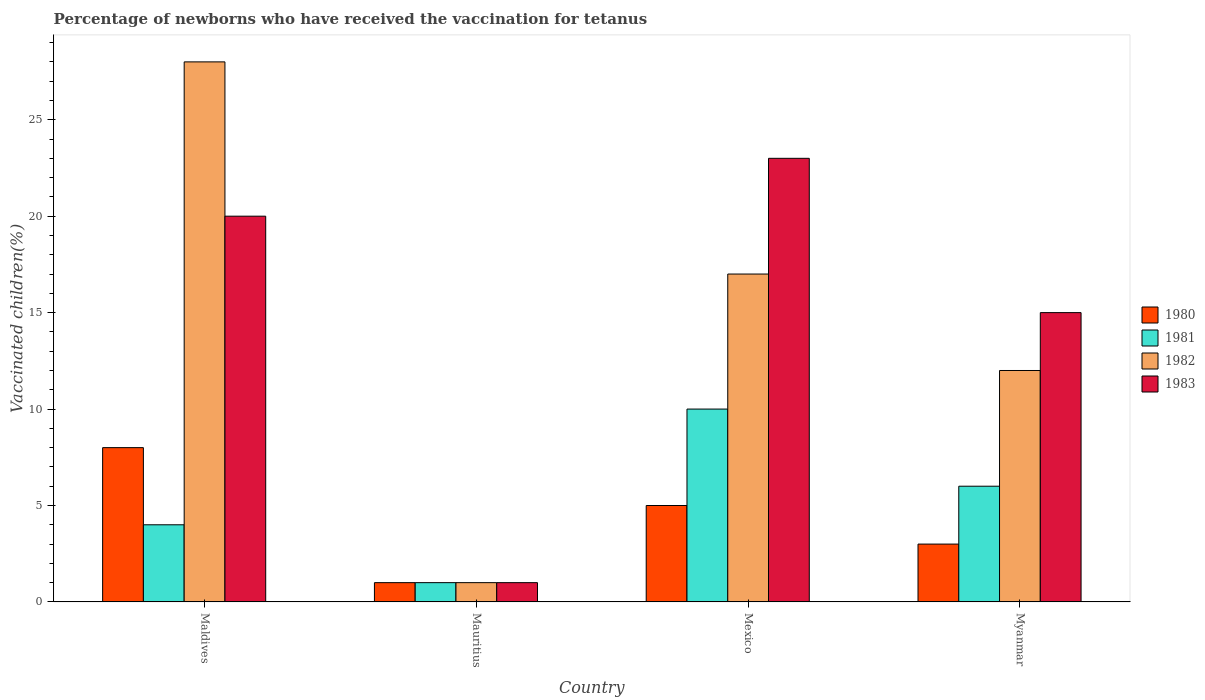Are the number of bars per tick equal to the number of legend labels?
Offer a terse response. Yes. Are the number of bars on each tick of the X-axis equal?
Ensure brevity in your answer.  Yes. What is the label of the 2nd group of bars from the left?
Your answer should be very brief. Mauritius. In which country was the percentage of vaccinated children in 1982 minimum?
Ensure brevity in your answer.  Mauritius. What is the total percentage of vaccinated children in 1981 in the graph?
Offer a terse response. 21. What is the difference between the percentage of vaccinated children in 1981 in Maldives and that in Mexico?
Provide a succinct answer. -6. What is the difference between the percentage of vaccinated children in 1982 in Mauritius and the percentage of vaccinated children in 1983 in Mexico?
Your answer should be compact. -22. What is the average percentage of vaccinated children in 1980 per country?
Provide a succinct answer. 4.25. What is the difference between the percentage of vaccinated children of/in 1981 and percentage of vaccinated children of/in 1982 in Myanmar?
Your answer should be very brief. -6. In how many countries, is the percentage of vaccinated children in 1982 greater than 12 %?
Provide a succinct answer. 2. What is the ratio of the percentage of vaccinated children in 1981 in Maldives to that in Myanmar?
Offer a very short reply. 0.67. In how many countries, is the percentage of vaccinated children in 1983 greater than the average percentage of vaccinated children in 1983 taken over all countries?
Offer a terse response. 3. Is the sum of the percentage of vaccinated children in 1980 in Maldives and Mauritius greater than the maximum percentage of vaccinated children in 1983 across all countries?
Offer a very short reply. No. How many bars are there?
Make the answer very short. 16. Are all the bars in the graph horizontal?
Keep it short and to the point. No. Does the graph contain any zero values?
Provide a succinct answer. No. Where does the legend appear in the graph?
Your answer should be compact. Center right. How are the legend labels stacked?
Your response must be concise. Vertical. What is the title of the graph?
Provide a succinct answer. Percentage of newborns who have received the vaccination for tetanus. What is the label or title of the Y-axis?
Provide a short and direct response. Vaccinated children(%). What is the Vaccinated children(%) in 1981 in Maldives?
Provide a short and direct response. 4. What is the Vaccinated children(%) in 1983 in Mauritius?
Ensure brevity in your answer.  1. What is the Vaccinated children(%) in 1982 in Myanmar?
Your response must be concise. 12. Across all countries, what is the maximum Vaccinated children(%) of 1981?
Your response must be concise. 10. Across all countries, what is the minimum Vaccinated children(%) in 1980?
Your answer should be compact. 1. Across all countries, what is the minimum Vaccinated children(%) of 1981?
Ensure brevity in your answer.  1. Across all countries, what is the minimum Vaccinated children(%) in 1982?
Ensure brevity in your answer.  1. What is the total Vaccinated children(%) of 1981 in the graph?
Your answer should be very brief. 21. What is the difference between the Vaccinated children(%) in 1980 in Maldives and that in Mauritius?
Your answer should be very brief. 7. What is the difference between the Vaccinated children(%) of 1982 in Maldives and that in Mauritius?
Make the answer very short. 27. What is the difference between the Vaccinated children(%) in 1983 in Maldives and that in Mauritius?
Give a very brief answer. 19. What is the difference between the Vaccinated children(%) of 1981 in Maldives and that in Myanmar?
Ensure brevity in your answer.  -2. What is the difference between the Vaccinated children(%) of 1983 in Maldives and that in Myanmar?
Keep it short and to the point. 5. What is the difference between the Vaccinated children(%) of 1980 in Mauritius and that in Mexico?
Your response must be concise. -4. What is the difference between the Vaccinated children(%) in 1981 in Mauritius and that in Mexico?
Give a very brief answer. -9. What is the difference between the Vaccinated children(%) in 1982 in Mauritius and that in Mexico?
Provide a succinct answer. -16. What is the difference between the Vaccinated children(%) in 1981 in Mauritius and that in Myanmar?
Give a very brief answer. -5. What is the difference between the Vaccinated children(%) in 1982 in Mauritius and that in Myanmar?
Your answer should be very brief. -11. What is the difference between the Vaccinated children(%) in 1983 in Mauritius and that in Myanmar?
Give a very brief answer. -14. What is the difference between the Vaccinated children(%) of 1981 in Mexico and that in Myanmar?
Give a very brief answer. 4. What is the difference between the Vaccinated children(%) in 1982 in Mexico and that in Myanmar?
Your response must be concise. 5. What is the difference between the Vaccinated children(%) in 1980 in Maldives and the Vaccinated children(%) in 1981 in Mauritius?
Offer a terse response. 7. What is the difference between the Vaccinated children(%) of 1980 in Maldives and the Vaccinated children(%) of 1982 in Mauritius?
Provide a succinct answer. 7. What is the difference between the Vaccinated children(%) of 1980 in Maldives and the Vaccinated children(%) of 1983 in Mauritius?
Offer a very short reply. 7. What is the difference between the Vaccinated children(%) of 1981 in Maldives and the Vaccinated children(%) of 1982 in Mauritius?
Your answer should be very brief. 3. What is the difference between the Vaccinated children(%) of 1980 in Maldives and the Vaccinated children(%) of 1981 in Mexico?
Your answer should be very brief. -2. What is the difference between the Vaccinated children(%) of 1980 in Maldives and the Vaccinated children(%) of 1982 in Mexico?
Ensure brevity in your answer.  -9. What is the difference between the Vaccinated children(%) of 1981 in Maldives and the Vaccinated children(%) of 1982 in Mexico?
Ensure brevity in your answer.  -13. What is the difference between the Vaccinated children(%) in 1980 in Maldives and the Vaccinated children(%) in 1981 in Myanmar?
Make the answer very short. 2. What is the difference between the Vaccinated children(%) of 1980 in Maldives and the Vaccinated children(%) of 1982 in Myanmar?
Your response must be concise. -4. What is the difference between the Vaccinated children(%) in 1981 in Maldives and the Vaccinated children(%) in 1983 in Myanmar?
Offer a very short reply. -11. What is the difference between the Vaccinated children(%) in 1982 in Maldives and the Vaccinated children(%) in 1983 in Myanmar?
Your answer should be very brief. 13. What is the difference between the Vaccinated children(%) of 1980 in Mauritius and the Vaccinated children(%) of 1983 in Mexico?
Keep it short and to the point. -22. What is the difference between the Vaccinated children(%) in 1981 in Mauritius and the Vaccinated children(%) in 1982 in Mexico?
Provide a succinct answer. -16. What is the difference between the Vaccinated children(%) of 1981 in Mauritius and the Vaccinated children(%) of 1983 in Mexico?
Your answer should be very brief. -22. What is the difference between the Vaccinated children(%) of 1980 in Mauritius and the Vaccinated children(%) of 1981 in Myanmar?
Provide a succinct answer. -5. What is the difference between the Vaccinated children(%) in 1980 in Mauritius and the Vaccinated children(%) in 1982 in Myanmar?
Offer a very short reply. -11. What is the difference between the Vaccinated children(%) of 1981 in Mauritius and the Vaccinated children(%) of 1982 in Myanmar?
Your answer should be very brief. -11. What is the difference between the Vaccinated children(%) of 1980 in Mexico and the Vaccinated children(%) of 1981 in Myanmar?
Ensure brevity in your answer.  -1. What is the difference between the Vaccinated children(%) of 1980 in Mexico and the Vaccinated children(%) of 1982 in Myanmar?
Give a very brief answer. -7. What is the difference between the Vaccinated children(%) of 1982 in Mexico and the Vaccinated children(%) of 1983 in Myanmar?
Provide a succinct answer. 2. What is the average Vaccinated children(%) of 1980 per country?
Give a very brief answer. 4.25. What is the average Vaccinated children(%) of 1981 per country?
Keep it short and to the point. 5.25. What is the average Vaccinated children(%) of 1982 per country?
Make the answer very short. 14.5. What is the average Vaccinated children(%) in 1983 per country?
Your answer should be very brief. 14.75. What is the difference between the Vaccinated children(%) of 1980 and Vaccinated children(%) of 1982 in Maldives?
Your answer should be compact. -20. What is the difference between the Vaccinated children(%) of 1980 and Vaccinated children(%) of 1983 in Maldives?
Your answer should be compact. -12. What is the difference between the Vaccinated children(%) in 1981 and Vaccinated children(%) in 1982 in Maldives?
Offer a very short reply. -24. What is the difference between the Vaccinated children(%) of 1982 and Vaccinated children(%) of 1983 in Maldives?
Offer a very short reply. 8. What is the difference between the Vaccinated children(%) in 1980 and Vaccinated children(%) in 1981 in Mauritius?
Offer a terse response. 0. What is the difference between the Vaccinated children(%) of 1980 and Vaccinated children(%) of 1983 in Mauritius?
Make the answer very short. 0. What is the difference between the Vaccinated children(%) of 1981 and Vaccinated children(%) of 1982 in Mauritius?
Make the answer very short. 0. What is the difference between the Vaccinated children(%) in 1981 and Vaccinated children(%) in 1983 in Mauritius?
Keep it short and to the point. 0. What is the difference between the Vaccinated children(%) in 1980 and Vaccinated children(%) in 1981 in Mexico?
Provide a short and direct response. -5. What is the difference between the Vaccinated children(%) of 1980 and Vaccinated children(%) of 1982 in Mexico?
Offer a very short reply. -12. What is the difference between the Vaccinated children(%) in 1982 and Vaccinated children(%) in 1983 in Mexico?
Your response must be concise. -6. What is the difference between the Vaccinated children(%) of 1980 and Vaccinated children(%) of 1983 in Myanmar?
Ensure brevity in your answer.  -12. What is the difference between the Vaccinated children(%) in 1981 and Vaccinated children(%) in 1983 in Myanmar?
Provide a short and direct response. -9. What is the ratio of the Vaccinated children(%) in 1981 in Maldives to that in Mauritius?
Offer a terse response. 4. What is the ratio of the Vaccinated children(%) of 1983 in Maldives to that in Mauritius?
Make the answer very short. 20. What is the ratio of the Vaccinated children(%) in 1981 in Maldives to that in Mexico?
Your answer should be compact. 0.4. What is the ratio of the Vaccinated children(%) in 1982 in Maldives to that in Mexico?
Keep it short and to the point. 1.65. What is the ratio of the Vaccinated children(%) in 1983 in Maldives to that in Mexico?
Offer a terse response. 0.87. What is the ratio of the Vaccinated children(%) of 1980 in Maldives to that in Myanmar?
Offer a very short reply. 2.67. What is the ratio of the Vaccinated children(%) in 1982 in Maldives to that in Myanmar?
Keep it short and to the point. 2.33. What is the ratio of the Vaccinated children(%) of 1983 in Maldives to that in Myanmar?
Offer a very short reply. 1.33. What is the ratio of the Vaccinated children(%) in 1982 in Mauritius to that in Mexico?
Your answer should be very brief. 0.06. What is the ratio of the Vaccinated children(%) of 1983 in Mauritius to that in Mexico?
Ensure brevity in your answer.  0.04. What is the ratio of the Vaccinated children(%) of 1982 in Mauritius to that in Myanmar?
Your answer should be very brief. 0.08. What is the ratio of the Vaccinated children(%) of 1983 in Mauritius to that in Myanmar?
Offer a very short reply. 0.07. What is the ratio of the Vaccinated children(%) in 1980 in Mexico to that in Myanmar?
Offer a terse response. 1.67. What is the ratio of the Vaccinated children(%) of 1982 in Mexico to that in Myanmar?
Your response must be concise. 1.42. What is the ratio of the Vaccinated children(%) in 1983 in Mexico to that in Myanmar?
Make the answer very short. 1.53. What is the difference between the highest and the second highest Vaccinated children(%) of 1981?
Keep it short and to the point. 4. What is the difference between the highest and the second highest Vaccinated children(%) of 1982?
Your response must be concise. 11. What is the difference between the highest and the second highest Vaccinated children(%) in 1983?
Ensure brevity in your answer.  3. What is the difference between the highest and the lowest Vaccinated children(%) of 1980?
Provide a succinct answer. 7. What is the difference between the highest and the lowest Vaccinated children(%) in 1981?
Provide a succinct answer. 9. 